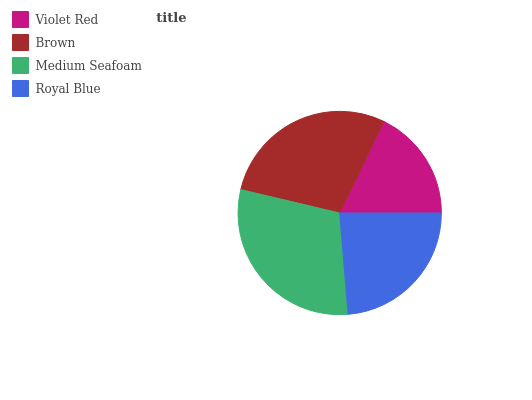Is Violet Red the minimum?
Answer yes or no. Yes. Is Medium Seafoam the maximum?
Answer yes or no. Yes. Is Brown the minimum?
Answer yes or no. No. Is Brown the maximum?
Answer yes or no. No. Is Brown greater than Violet Red?
Answer yes or no. Yes. Is Violet Red less than Brown?
Answer yes or no. Yes. Is Violet Red greater than Brown?
Answer yes or no. No. Is Brown less than Violet Red?
Answer yes or no. No. Is Brown the high median?
Answer yes or no. Yes. Is Royal Blue the low median?
Answer yes or no. Yes. Is Violet Red the high median?
Answer yes or no. No. Is Brown the low median?
Answer yes or no. No. 